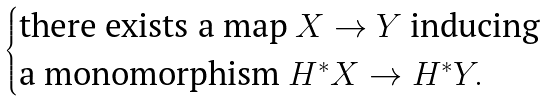Convert formula to latex. <formula><loc_0><loc_0><loc_500><loc_500>\begin{cases} \text {there exists a map } X \to Y \text { inducing} \\ \text {a monomorphism } H ^ { * } X \to H ^ { * } Y . \end{cases}</formula> 